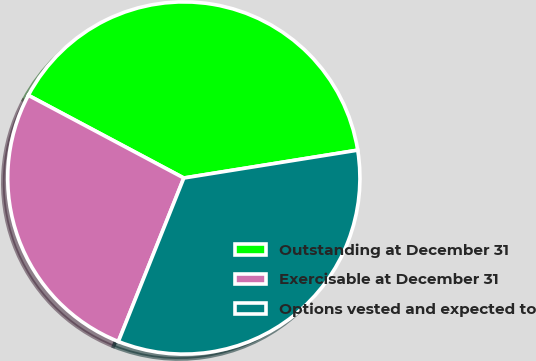<chart> <loc_0><loc_0><loc_500><loc_500><pie_chart><fcel>Outstanding at December 31<fcel>Exercisable at December 31<fcel>Options vested and expected to<nl><fcel>39.69%<fcel>26.72%<fcel>33.59%<nl></chart> 